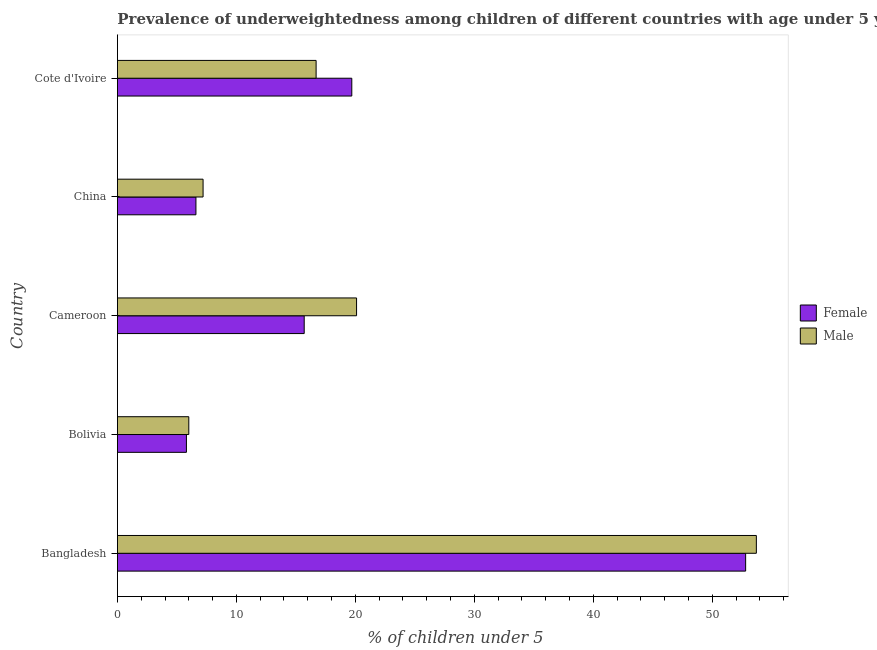Are the number of bars on each tick of the Y-axis equal?
Your response must be concise. Yes. How many bars are there on the 1st tick from the bottom?
Offer a very short reply. 2. What is the label of the 3rd group of bars from the top?
Your answer should be compact. Cameroon. What is the percentage of underweighted female children in Bangladesh?
Your answer should be very brief. 52.8. Across all countries, what is the maximum percentage of underweighted female children?
Offer a very short reply. 52.8. Across all countries, what is the minimum percentage of underweighted male children?
Give a very brief answer. 6. What is the total percentage of underweighted female children in the graph?
Provide a succinct answer. 100.6. What is the difference between the percentage of underweighted female children in Bolivia and that in Cameroon?
Make the answer very short. -9.9. What is the difference between the percentage of underweighted male children in Bangladesh and the percentage of underweighted female children in Cote d'Ivoire?
Your answer should be very brief. 34. What is the average percentage of underweighted male children per country?
Ensure brevity in your answer.  20.74. What is the ratio of the percentage of underweighted male children in China to that in Cote d'Ivoire?
Offer a terse response. 0.43. What is the difference between the highest and the second highest percentage of underweighted male children?
Your answer should be very brief. 33.6. Are all the bars in the graph horizontal?
Your answer should be compact. Yes. Are the values on the major ticks of X-axis written in scientific E-notation?
Keep it short and to the point. No. Does the graph contain grids?
Your response must be concise. No. Where does the legend appear in the graph?
Provide a short and direct response. Center right. How many legend labels are there?
Your answer should be very brief. 2. What is the title of the graph?
Your response must be concise. Prevalence of underweightedness among children of different countries with age under 5 years. What is the label or title of the X-axis?
Provide a short and direct response.  % of children under 5. What is the label or title of the Y-axis?
Offer a very short reply. Country. What is the  % of children under 5 of Female in Bangladesh?
Make the answer very short. 52.8. What is the  % of children under 5 in Male in Bangladesh?
Offer a very short reply. 53.7. What is the  % of children under 5 of Female in Bolivia?
Give a very brief answer. 5.8. What is the  % of children under 5 in Male in Bolivia?
Your answer should be compact. 6. What is the  % of children under 5 in Female in Cameroon?
Offer a very short reply. 15.7. What is the  % of children under 5 in Male in Cameroon?
Your answer should be very brief. 20.1. What is the  % of children under 5 of Female in China?
Your answer should be very brief. 6.6. What is the  % of children under 5 of Male in China?
Provide a short and direct response. 7.2. What is the  % of children under 5 of Female in Cote d'Ivoire?
Offer a very short reply. 19.7. What is the  % of children under 5 in Male in Cote d'Ivoire?
Offer a terse response. 16.7. Across all countries, what is the maximum  % of children under 5 of Female?
Offer a terse response. 52.8. Across all countries, what is the maximum  % of children under 5 in Male?
Ensure brevity in your answer.  53.7. Across all countries, what is the minimum  % of children under 5 in Female?
Offer a terse response. 5.8. Across all countries, what is the minimum  % of children under 5 in Male?
Make the answer very short. 6. What is the total  % of children under 5 in Female in the graph?
Your answer should be compact. 100.6. What is the total  % of children under 5 of Male in the graph?
Provide a short and direct response. 103.7. What is the difference between the  % of children under 5 of Male in Bangladesh and that in Bolivia?
Keep it short and to the point. 47.7. What is the difference between the  % of children under 5 of Female in Bangladesh and that in Cameroon?
Ensure brevity in your answer.  37.1. What is the difference between the  % of children under 5 in Male in Bangladesh and that in Cameroon?
Keep it short and to the point. 33.6. What is the difference between the  % of children under 5 of Female in Bangladesh and that in China?
Provide a short and direct response. 46.2. What is the difference between the  % of children under 5 of Male in Bangladesh and that in China?
Give a very brief answer. 46.5. What is the difference between the  % of children under 5 of Female in Bangladesh and that in Cote d'Ivoire?
Provide a succinct answer. 33.1. What is the difference between the  % of children under 5 in Male in Bolivia and that in Cameroon?
Your response must be concise. -14.1. What is the difference between the  % of children under 5 of Female in Bolivia and that in Cote d'Ivoire?
Ensure brevity in your answer.  -13.9. What is the difference between the  % of children under 5 in Male in Bolivia and that in Cote d'Ivoire?
Provide a succinct answer. -10.7. What is the difference between the  % of children under 5 of Female in Cameroon and that in China?
Your response must be concise. 9.1. What is the difference between the  % of children under 5 of Male in Cameroon and that in Cote d'Ivoire?
Ensure brevity in your answer.  3.4. What is the difference between the  % of children under 5 in Female in China and that in Cote d'Ivoire?
Your answer should be compact. -13.1. What is the difference between the  % of children under 5 in Female in Bangladesh and the  % of children under 5 in Male in Bolivia?
Your answer should be compact. 46.8. What is the difference between the  % of children under 5 of Female in Bangladesh and the  % of children under 5 of Male in Cameroon?
Offer a very short reply. 32.7. What is the difference between the  % of children under 5 of Female in Bangladesh and the  % of children under 5 of Male in China?
Make the answer very short. 45.6. What is the difference between the  % of children under 5 of Female in Bangladesh and the  % of children under 5 of Male in Cote d'Ivoire?
Provide a succinct answer. 36.1. What is the difference between the  % of children under 5 of Female in Bolivia and the  % of children under 5 of Male in Cameroon?
Ensure brevity in your answer.  -14.3. What is the difference between the  % of children under 5 in Female in Bolivia and the  % of children under 5 in Male in China?
Give a very brief answer. -1.4. What is the difference between the  % of children under 5 of Female in Bolivia and the  % of children under 5 of Male in Cote d'Ivoire?
Provide a succinct answer. -10.9. What is the average  % of children under 5 in Female per country?
Make the answer very short. 20.12. What is the average  % of children under 5 in Male per country?
Offer a terse response. 20.74. What is the difference between the  % of children under 5 in Female and  % of children under 5 in Male in China?
Keep it short and to the point. -0.6. What is the difference between the  % of children under 5 in Female and  % of children under 5 in Male in Cote d'Ivoire?
Provide a succinct answer. 3. What is the ratio of the  % of children under 5 of Female in Bangladesh to that in Bolivia?
Your answer should be compact. 9.1. What is the ratio of the  % of children under 5 in Male in Bangladesh to that in Bolivia?
Provide a short and direct response. 8.95. What is the ratio of the  % of children under 5 in Female in Bangladesh to that in Cameroon?
Offer a very short reply. 3.36. What is the ratio of the  % of children under 5 of Male in Bangladesh to that in Cameroon?
Offer a very short reply. 2.67. What is the ratio of the  % of children under 5 of Female in Bangladesh to that in China?
Make the answer very short. 8. What is the ratio of the  % of children under 5 in Male in Bangladesh to that in China?
Make the answer very short. 7.46. What is the ratio of the  % of children under 5 in Female in Bangladesh to that in Cote d'Ivoire?
Keep it short and to the point. 2.68. What is the ratio of the  % of children under 5 in Male in Bangladesh to that in Cote d'Ivoire?
Your answer should be very brief. 3.22. What is the ratio of the  % of children under 5 in Female in Bolivia to that in Cameroon?
Your answer should be compact. 0.37. What is the ratio of the  % of children under 5 of Male in Bolivia to that in Cameroon?
Ensure brevity in your answer.  0.3. What is the ratio of the  % of children under 5 in Female in Bolivia to that in China?
Provide a succinct answer. 0.88. What is the ratio of the  % of children under 5 of Female in Bolivia to that in Cote d'Ivoire?
Your answer should be very brief. 0.29. What is the ratio of the  % of children under 5 in Male in Bolivia to that in Cote d'Ivoire?
Offer a very short reply. 0.36. What is the ratio of the  % of children under 5 of Female in Cameroon to that in China?
Your answer should be very brief. 2.38. What is the ratio of the  % of children under 5 of Male in Cameroon to that in China?
Your answer should be compact. 2.79. What is the ratio of the  % of children under 5 in Female in Cameroon to that in Cote d'Ivoire?
Your answer should be compact. 0.8. What is the ratio of the  % of children under 5 of Male in Cameroon to that in Cote d'Ivoire?
Keep it short and to the point. 1.2. What is the ratio of the  % of children under 5 of Female in China to that in Cote d'Ivoire?
Offer a terse response. 0.34. What is the ratio of the  % of children under 5 of Male in China to that in Cote d'Ivoire?
Offer a very short reply. 0.43. What is the difference between the highest and the second highest  % of children under 5 in Female?
Provide a succinct answer. 33.1. What is the difference between the highest and the second highest  % of children under 5 of Male?
Offer a very short reply. 33.6. What is the difference between the highest and the lowest  % of children under 5 in Male?
Your response must be concise. 47.7. 